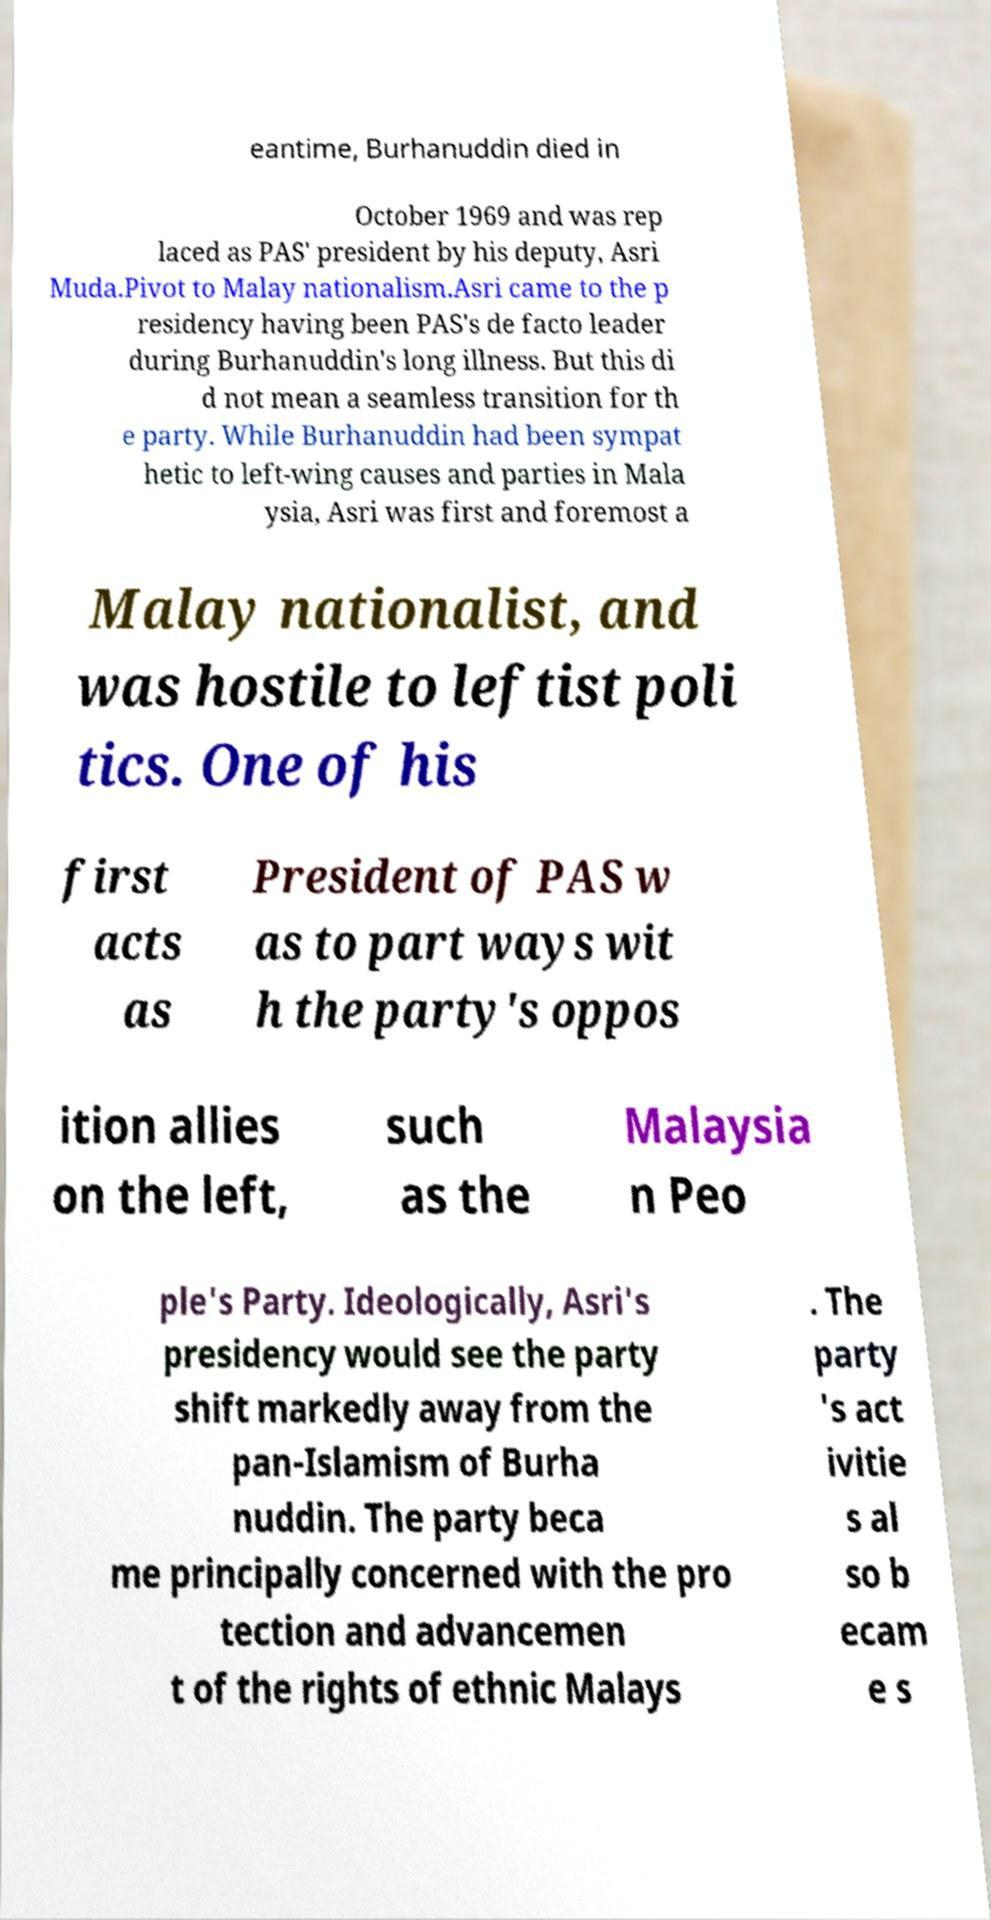Could you extract and type out the text from this image? eantime, Burhanuddin died in October 1969 and was rep laced as PAS' president by his deputy, Asri Muda.Pivot to Malay nationalism.Asri came to the p residency having been PAS's de facto leader during Burhanuddin's long illness. But this di d not mean a seamless transition for th e party. While Burhanuddin had been sympat hetic to left-wing causes and parties in Mala ysia, Asri was first and foremost a Malay nationalist, and was hostile to leftist poli tics. One of his first acts as President of PAS w as to part ways wit h the party's oppos ition allies on the left, such as the Malaysia n Peo ple's Party. Ideologically, Asri's presidency would see the party shift markedly away from the pan-Islamism of Burha nuddin. The party beca me principally concerned with the pro tection and advancemen t of the rights of ethnic Malays . The party 's act ivitie s al so b ecam e s 